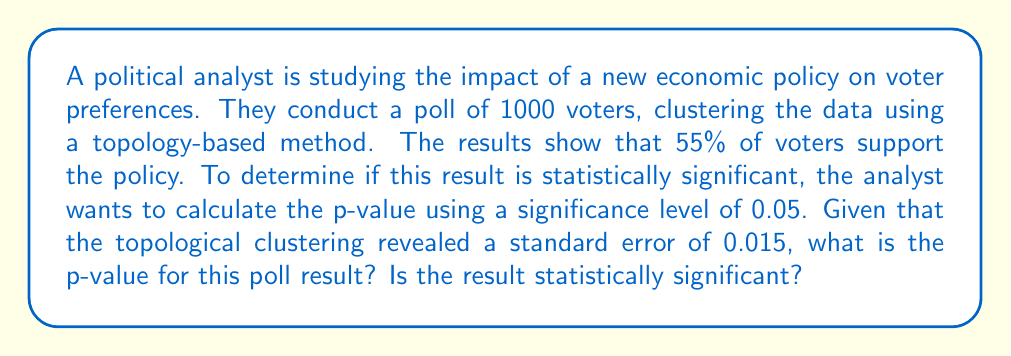Provide a solution to this math problem. To determine the statistical significance of the poll results, we need to calculate the p-value and compare it to the given significance level of 0.05. Here's how we can approach this problem:

1. First, we need to calculate the z-score for our poll result. The formula for the z-score is:

   $$z = \frac{\hat{p} - p_0}{\sqrt{\frac{p_0(1-p_0)}{n}}}$$

   Where:
   $\hat{p}$ is the sample proportion (0.55 in this case)
   $p_0$ is the null hypothesis proportion (0.50, assuming no preference)
   $n$ is the sample size (1000)

2. Calculate the z-score:

   $$z = \frac{0.55 - 0.50}{\sqrt{\frac{0.50(1-0.50)}{1000}}} = \frac{0.05}{0.015} = 3.33$$

3. Now, we need to find the area under the standard normal curve beyond this z-score. This is typically done using a z-table or statistical software. However, we can use the given standard error from the topological clustering to simplify this process.

4. The p-value for a two-tailed test is calculated as:

   $$p = 2 \cdot P(Z > |z|)$$

5. Given the standard error (SE) of 0.015 from the topological clustering, we can calculate the p-value using the normal distribution properties:

   $$p = 2 \cdot P(Z > \frac{|0.55 - 0.50|}{0.015})$$
   $$p = 2 \cdot P(Z > 3.33)$$

6. Using a standard normal distribution table or calculator, we find:

   $$P(Z > 3.33) \approx 0.00043$$

7. Therefore, the p-value is:

   $$p = 2 \cdot 0.00043 = 0.00086$$

8. Compare this p-value to the significance level of 0.05:

   0.00086 < 0.05

Since the p-value (0.00086) is less than the significance level (0.05), we reject the null hypothesis. This means the result is statistically significant.
Answer: The p-value is approximately 0.00086, which is less than the significance level of 0.05. Therefore, the poll result is statistically significant. 